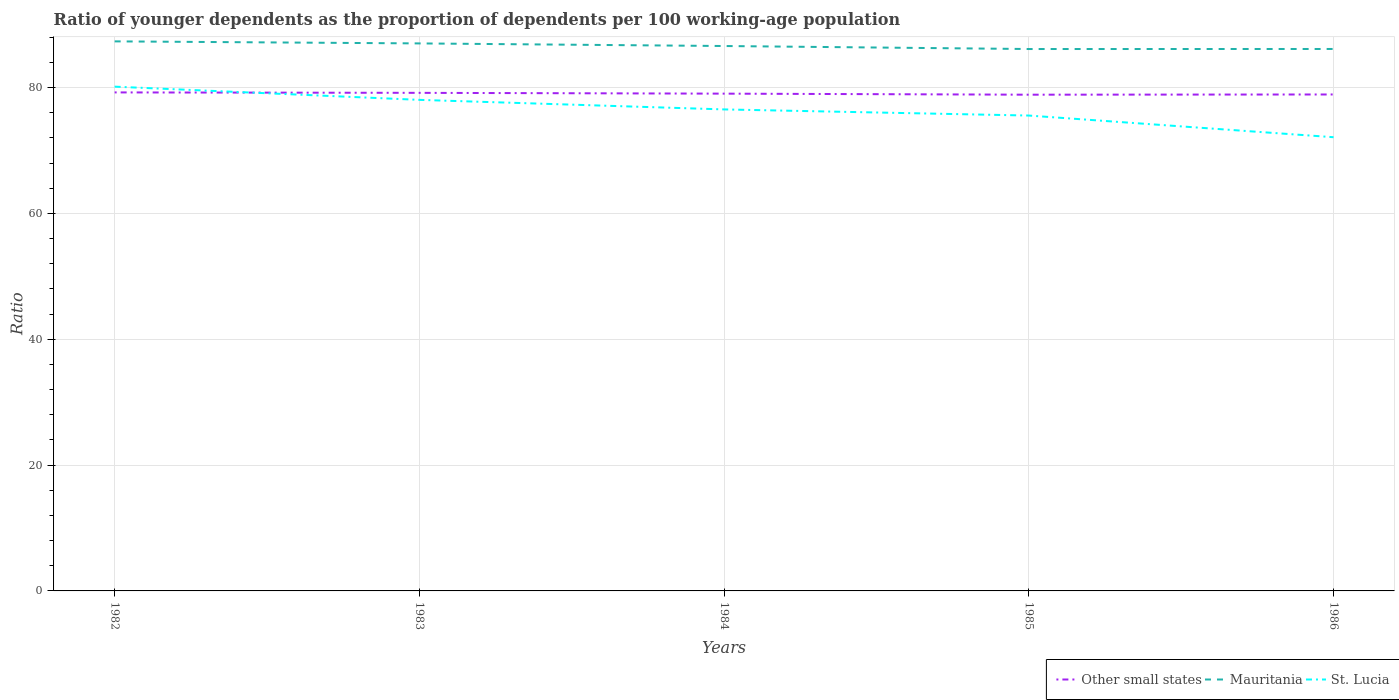How many different coloured lines are there?
Ensure brevity in your answer.  3. Is the number of lines equal to the number of legend labels?
Offer a very short reply. Yes. Across all years, what is the maximum age dependency ratio(young) in Other small states?
Offer a very short reply. 78.86. In which year was the age dependency ratio(young) in Mauritania maximum?
Give a very brief answer. 1985. What is the total age dependency ratio(young) in Mauritania in the graph?
Provide a short and direct response. -0.01. What is the difference between the highest and the second highest age dependency ratio(young) in Other small states?
Offer a very short reply. 0.36. What is the difference between the highest and the lowest age dependency ratio(young) in St. Lucia?
Make the answer very short. 3. How many lines are there?
Offer a very short reply. 3. How many years are there in the graph?
Your answer should be very brief. 5. What is the difference between two consecutive major ticks on the Y-axis?
Offer a terse response. 20. Does the graph contain any zero values?
Provide a short and direct response. No. What is the title of the graph?
Keep it short and to the point. Ratio of younger dependents as the proportion of dependents per 100 working-age population. Does "Mauritius" appear as one of the legend labels in the graph?
Offer a terse response. No. What is the label or title of the Y-axis?
Give a very brief answer. Ratio. What is the Ratio in Other small states in 1982?
Keep it short and to the point. 79.22. What is the Ratio of Mauritania in 1982?
Ensure brevity in your answer.  87.33. What is the Ratio in St. Lucia in 1982?
Offer a very short reply. 80.14. What is the Ratio in Other small states in 1983?
Provide a succinct answer. 79.15. What is the Ratio of Mauritania in 1983?
Offer a very short reply. 87.01. What is the Ratio in St. Lucia in 1983?
Provide a short and direct response. 78.04. What is the Ratio in Other small states in 1984?
Give a very brief answer. 79.02. What is the Ratio in Mauritania in 1984?
Make the answer very short. 86.59. What is the Ratio in St. Lucia in 1984?
Provide a short and direct response. 76.52. What is the Ratio in Other small states in 1985?
Offer a very short reply. 78.86. What is the Ratio of Mauritania in 1985?
Provide a succinct answer. 86.11. What is the Ratio in St. Lucia in 1985?
Offer a very short reply. 75.54. What is the Ratio in Other small states in 1986?
Provide a short and direct response. 78.89. What is the Ratio in Mauritania in 1986?
Make the answer very short. 86.12. What is the Ratio of St. Lucia in 1986?
Your response must be concise. 72.1. Across all years, what is the maximum Ratio of Other small states?
Provide a succinct answer. 79.22. Across all years, what is the maximum Ratio of Mauritania?
Your response must be concise. 87.33. Across all years, what is the maximum Ratio in St. Lucia?
Keep it short and to the point. 80.14. Across all years, what is the minimum Ratio of Other small states?
Ensure brevity in your answer.  78.86. Across all years, what is the minimum Ratio in Mauritania?
Make the answer very short. 86.11. Across all years, what is the minimum Ratio in St. Lucia?
Your answer should be very brief. 72.1. What is the total Ratio of Other small states in the graph?
Offer a very short reply. 395.15. What is the total Ratio in Mauritania in the graph?
Your answer should be compact. 433.17. What is the total Ratio of St. Lucia in the graph?
Give a very brief answer. 382.33. What is the difference between the Ratio in Other small states in 1982 and that in 1983?
Make the answer very short. 0.07. What is the difference between the Ratio of Mauritania in 1982 and that in 1983?
Ensure brevity in your answer.  0.33. What is the difference between the Ratio in St. Lucia in 1982 and that in 1983?
Offer a terse response. 2.1. What is the difference between the Ratio in Other small states in 1982 and that in 1984?
Your answer should be very brief. 0.2. What is the difference between the Ratio in Mauritania in 1982 and that in 1984?
Provide a succinct answer. 0.74. What is the difference between the Ratio in St. Lucia in 1982 and that in 1984?
Keep it short and to the point. 3.62. What is the difference between the Ratio of Other small states in 1982 and that in 1985?
Provide a succinct answer. 0.36. What is the difference between the Ratio in Mauritania in 1982 and that in 1985?
Make the answer very short. 1.22. What is the difference between the Ratio in St. Lucia in 1982 and that in 1985?
Make the answer very short. 4.59. What is the difference between the Ratio of Other small states in 1982 and that in 1986?
Ensure brevity in your answer.  0.33. What is the difference between the Ratio of Mauritania in 1982 and that in 1986?
Make the answer very short. 1.21. What is the difference between the Ratio in St. Lucia in 1982 and that in 1986?
Offer a very short reply. 8.04. What is the difference between the Ratio in Other small states in 1983 and that in 1984?
Your response must be concise. 0.13. What is the difference between the Ratio in Mauritania in 1983 and that in 1984?
Ensure brevity in your answer.  0.41. What is the difference between the Ratio of St. Lucia in 1983 and that in 1984?
Your answer should be compact. 1.52. What is the difference between the Ratio of Other small states in 1983 and that in 1985?
Offer a terse response. 0.29. What is the difference between the Ratio of Mauritania in 1983 and that in 1985?
Keep it short and to the point. 0.89. What is the difference between the Ratio in St. Lucia in 1983 and that in 1985?
Ensure brevity in your answer.  2.49. What is the difference between the Ratio of Other small states in 1983 and that in 1986?
Your response must be concise. 0.26. What is the difference between the Ratio of Mauritania in 1983 and that in 1986?
Keep it short and to the point. 0.88. What is the difference between the Ratio in St. Lucia in 1983 and that in 1986?
Offer a very short reply. 5.94. What is the difference between the Ratio of Other small states in 1984 and that in 1985?
Your answer should be compact. 0.17. What is the difference between the Ratio in Mauritania in 1984 and that in 1985?
Ensure brevity in your answer.  0.48. What is the difference between the Ratio in St. Lucia in 1984 and that in 1985?
Offer a very short reply. 0.97. What is the difference between the Ratio in Other small states in 1984 and that in 1986?
Provide a short and direct response. 0.13. What is the difference between the Ratio of Mauritania in 1984 and that in 1986?
Provide a succinct answer. 0.47. What is the difference between the Ratio in St. Lucia in 1984 and that in 1986?
Provide a succinct answer. 4.42. What is the difference between the Ratio of Other small states in 1985 and that in 1986?
Offer a very short reply. -0.04. What is the difference between the Ratio in Mauritania in 1985 and that in 1986?
Provide a short and direct response. -0.01. What is the difference between the Ratio of St. Lucia in 1985 and that in 1986?
Your response must be concise. 3.44. What is the difference between the Ratio of Other small states in 1982 and the Ratio of Mauritania in 1983?
Ensure brevity in your answer.  -7.79. What is the difference between the Ratio in Other small states in 1982 and the Ratio in St. Lucia in 1983?
Ensure brevity in your answer.  1.19. What is the difference between the Ratio of Mauritania in 1982 and the Ratio of St. Lucia in 1983?
Offer a very short reply. 9.3. What is the difference between the Ratio in Other small states in 1982 and the Ratio in Mauritania in 1984?
Give a very brief answer. -7.37. What is the difference between the Ratio in Other small states in 1982 and the Ratio in St. Lucia in 1984?
Ensure brevity in your answer.  2.7. What is the difference between the Ratio in Mauritania in 1982 and the Ratio in St. Lucia in 1984?
Give a very brief answer. 10.82. What is the difference between the Ratio in Other small states in 1982 and the Ratio in Mauritania in 1985?
Keep it short and to the point. -6.89. What is the difference between the Ratio of Other small states in 1982 and the Ratio of St. Lucia in 1985?
Offer a terse response. 3.68. What is the difference between the Ratio of Mauritania in 1982 and the Ratio of St. Lucia in 1985?
Your answer should be very brief. 11.79. What is the difference between the Ratio of Other small states in 1982 and the Ratio of Mauritania in 1986?
Your answer should be very brief. -6.9. What is the difference between the Ratio in Other small states in 1982 and the Ratio in St. Lucia in 1986?
Your answer should be compact. 7.12. What is the difference between the Ratio in Mauritania in 1982 and the Ratio in St. Lucia in 1986?
Your response must be concise. 15.23. What is the difference between the Ratio in Other small states in 1983 and the Ratio in Mauritania in 1984?
Your response must be concise. -7.44. What is the difference between the Ratio in Other small states in 1983 and the Ratio in St. Lucia in 1984?
Offer a very short reply. 2.64. What is the difference between the Ratio in Mauritania in 1983 and the Ratio in St. Lucia in 1984?
Make the answer very short. 10.49. What is the difference between the Ratio of Other small states in 1983 and the Ratio of Mauritania in 1985?
Ensure brevity in your answer.  -6.96. What is the difference between the Ratio in Other small states in 1983 and the Ratio in St. Lucia in 1985?
Your answer should be compact. 3.61. What is the difference between the Ratio in Mauritania in 1983 and the Ratio in St. Lucia in 1985?
Provide a short and direct response. 11.46. What is the difference between the Ratio of Other small states in 1983 and the Ratio of Mauritania in 1986?
Your answer should be compact. -6.97. What is the difference between the Ratio of Other small states in 1983 and the Ratio of St. Lucia in 1986?
Offer a very short reply. 7.05. What is the difference between the Ratio of Mauritania in 1983 and the Ratio of St. Lucia in 1986?
Ensure brevity in your answer.  14.91. What is the difference between the Ratio of Other small states in 1984 and the Ratio of Mauritania in 1985?
Your response must be concise. -7.09. What is the difference between the Ratio in Other small states in 1984 and the Ratio in St. Lucia in 1985?
Provide a succinct answer. 3.48. What is the difference between the Ratio in Mauritania in 1984 and the Ratio in St. Lucia in 1985?
Your response must be concise. 11.05. What is the difference between the Ratio in Other small states in 1984 and the Ratio in Mauritania in 1986?
Offer a terse response. -7.1. What is the difference between the Ratio in Other small states in 1984 and the Ratio in St. Lucia in 1986?
Your answer should be very brief. 6.92. What is the difference between the Ratio of Mauritania in 1984 and the Ratio of St. Lucia in 1986?
Keep it short and to the point. 14.49. What is the difference between the Ratio of Other small states in 1985 and the Ratio of Mauritania in 1986?
Provide a short and direct response. -7.27. What is the difference between the Ratio in Other small states in 1985 and the Ratio in St. Lucia in 1986?
Provide a succinct answer. 6.76. What is the difference between the Ratio in Mauritania in 1985 and the Ratio in St. Lucia in 1986?
Offer a very short reply. 14.01. What is the average Ratio of Other small states per year?
Ensure brevity in your answer.  79.03. What is the average Ratio in Mauritania per year?
Provide a short and direct response. 86.63. What is the average Ratio of St. Lucia per year?
Your answer should be compact. 76.47. In the year 1982, what is the difference between the Ratio in Other small states and Ratio in Mauritania?
Give a very brief answer. -8.11. In the year 1982, what is the difference between the Ratio of Other small states and Ratio of St. Lucia?
Keep it short and to the point. -0.92. In the year 1982, what is the difference between the Ratio in Mauritania and Ratio in St. Lucia?
Your answer should be compact. 7.19. In the year 1983, what is the difference between the Ratio in Other small states and Ratio in Mauritania?
Your answer should be very brief. -7.85. In the year 1983, what is the difference between the Ratio in Other small states and Ratio in St. Lucia?
Your response must be concise. 1.12. In the year 1983, what is the difference between the Ratio of Mauritania and Ratio of St. Lucia?
Your response must be concise. 8.97. In the year 1984, what is the difference between the Ratio in Other small states and Ratio in Mauritania?
Keep it short and to the point. -7.57. In the year 1984, what is the difference between the Ratio in Other small states and Ratio in St. Lucia?
Your response must be concise. 2.51. In the year 1984, what is the difference between the Ratio of Mauritania and Ratio of St. Lucia?
Your answer should be compact. 10.08. In the year 1985, what is the difference between the Ratio in Other small states and Ratio in Mauritania?
Provide a short and direct response. -7.26. In the year 1985, what is the difference between the Ratio in Other small states and Ratio in St. Lucia?
Give a very brief answer. 3.31. In the year 1985, what is the difference between the Ratio in Mauritania and Ratio in St. Lucia?
Give a very brief answer. 10.57. In the year 1986, what is the difference between the Ratio in Other small states and Ratio in Mauritania?
Make the answer very short. -7.23. In the year 1986, what is the difference between the Ratio in Other small states and Ratio in St. Lucia?
Provide a succinct answer. 6.79. In the year 1986, what is the difference between the Ratio of Mauritania and Ratio of St. Lucia?
Provide a succinct answer. 14.02. What is the ratio of the Ratio of St. Lucia in 1982 to that in 1983?
Your response must be concise. 1.03. What is the ratio of the Ratio in Other small states in 1982 to that in 1984?
Your answer should be very brief. 1. What is the ratio of the Ratio of Mauritania in 1982 to that in 1984?
Keep it short and to the point. 1.01. What is the ratio of the Ratio in St. Lucia in 1982 to that in 1984?
Provide a succinct answer. 1.05. What is the ratio of the Ratio in Other small states in 1982 to that in 1985?
Your answer should be very brief. 1. What is the ratio of the Ratio of Mauritania in 1982 to that in 1985?
Offer a very short reply. 1.01. What is the ratio of the Ratio of St. Lucia in 1982 to that in 1985?
Your answer should be very brief. 1.06. What is the ratio of the Ratio of Mauritania in 1982 to that in 1986?
Make the answer very short. 1.01. What is the ratio of the Ratio in St. Lucia in 1982 to that in 1986?
Provide a succinct answer. 1.11. What is the ratio of the Ratio in Other small states in 1983 to that in 1984?
Provide a short and direct response. 1. What is the ratio of the Ratio of Mauritania in 1983 to that in 1984?
Ensure brevity in your answer.  1. What is the ratio of the Ratio in St. Lucia in 1983 to that in 1984?
Make the answer very short. 1.02. What is the ratio of the Ratio of Mauritania in 1983 to that in 1985?
Offer a terse response. 1.01. What is the ratio of the Ratio of St. Lucia in 1983 to that in 1985?
Offer a very short reply. 1.03. What is the ratio of the Ratio in Other small states in 1983 to that in 1986?
Offer a terse response. 1. What is the ratio of the Ratio of Mauritania in 1983 to that in 1986?
Your answer should be very brief. 1.01. What is the ratio of the Ratio of St. Lucia in 1983 to that in 1986?
Your answer should be very brief. 1.08. What is the ratio of the Ratio of Mauritania in 1984 to that in 1985?
Provide a succinct answer. 1.01. What is the ratio of the Ratio of St. Lucia in 1984 to that in 1985?
Keep it short and to the point. 1.01. What is the ratio of the Ratio of Other small states in 1984 to that in 1986?
Offer a very short reply. 1. What is the ratio of the Ratio in Mauritania in 1984 to that in 1986?
Provide a succinct answer. 1.01. What is the ratio of the Ratio in St. Lucia in 1984 to that in 1986?
Keep it short and to the point. 1.06. What is the ratio of the Ratio in St. Lucia in 1985 to that in 1986?
Provide a succinct answer. 1.05. What is the difference between the highest and the second highest Ratio in Other small states?
Make the answer very short. 0.07. What is the difference between the highest and the second highest Ratio in Mauritania?
Ensure brevity in your answer.  0.33. What is the difference between the highest and the second highest Ratio in St. Lucia?
Your answer should be very brief. 2.1. What is the difference between the highest and the lowest Ratio of Other small states?
Your response must be concise. 0.36. What is the difference between the highest and the lowest Ratio in Mauritania?
Provide a succinct answer. 1.22. What is the difference between the highest and the lowest Ratio in St. Lucia?
Offer a very short reply. 8.04. 